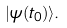<formula> <loc_0><loc_0><loc_500><loc_500>| \psi ( t _ { 0 } ) \rangle .</formula> 